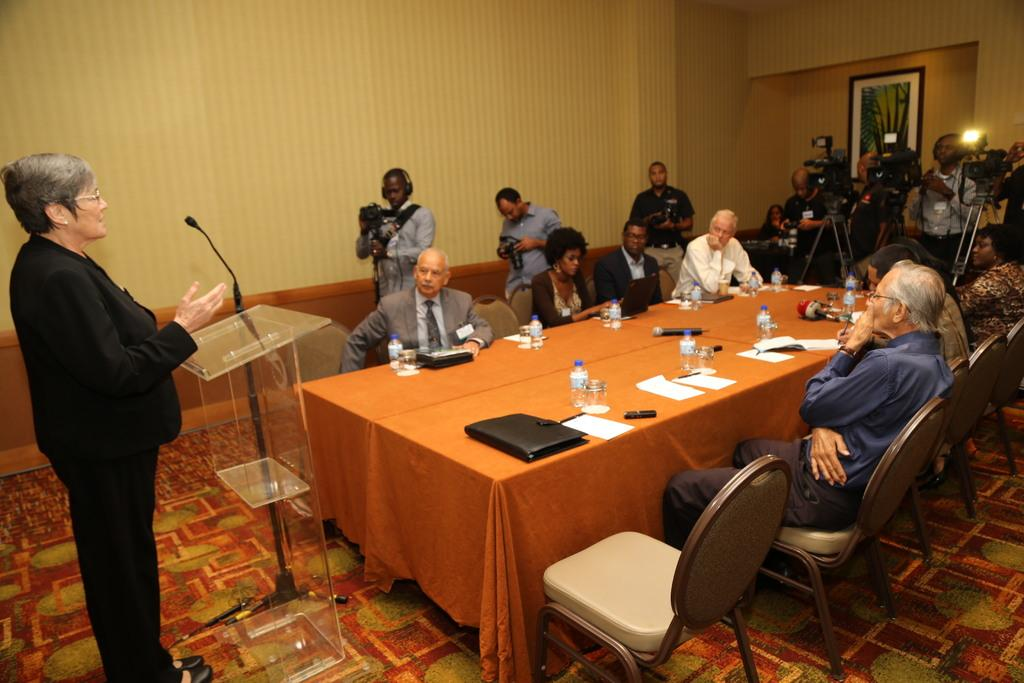What are the people in the image doing? The people in the image are sitting on chairs and standing while holding cameras. What objects can be seen on the table? There is a bottle, a paper, a file, and a glass on the table. Is there any indication of the location being downtown in the image? No, there is no indication of the location being downtown in the image. What word is written on the paper on the table? There is no specific word visible on the paper in the image? What type of tray is being used to serve food in the image? There is no tray present in the image, and no food is being served. 